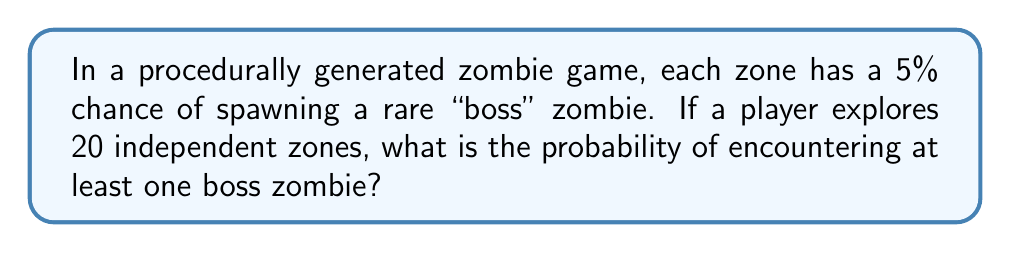Provide a solution to this math problem. Let's approach this step-by-step:

1) First, let's define our events:
   - Let A be the event of encountering at least one boss zombie
   - Let B be the event of not encountering any boss zombies

2) We're looking for P(A), but it's easier to calculate P(B) and then use the complement rule:

   P(A) = 1 - P(B)

3) For B to occur, we need to not encounter a boss zombie in any of the 20 zones. The probability of not encountering a boss in a single zone is 0.95 (1 - 0.05).

4) Since the zones are independent, we can multiply these probabilities:

   P(B) = $0.95^{20}$

5) Now we can calculate:

   P(A) = 1 - P(B) = 1 - $0.95^{20}$

6) Let's compute this:
   
   $1 - 0.95^{20} \approx 1 - 0.3585 = 0.6415$

7) Converting to a percentage:

   0.6415 * 100% ≈ 64.15%

Therefore, the probability of encountering at least one boss zombie in 20 zones is approximately 64.15%.
Answer: 64.15% 